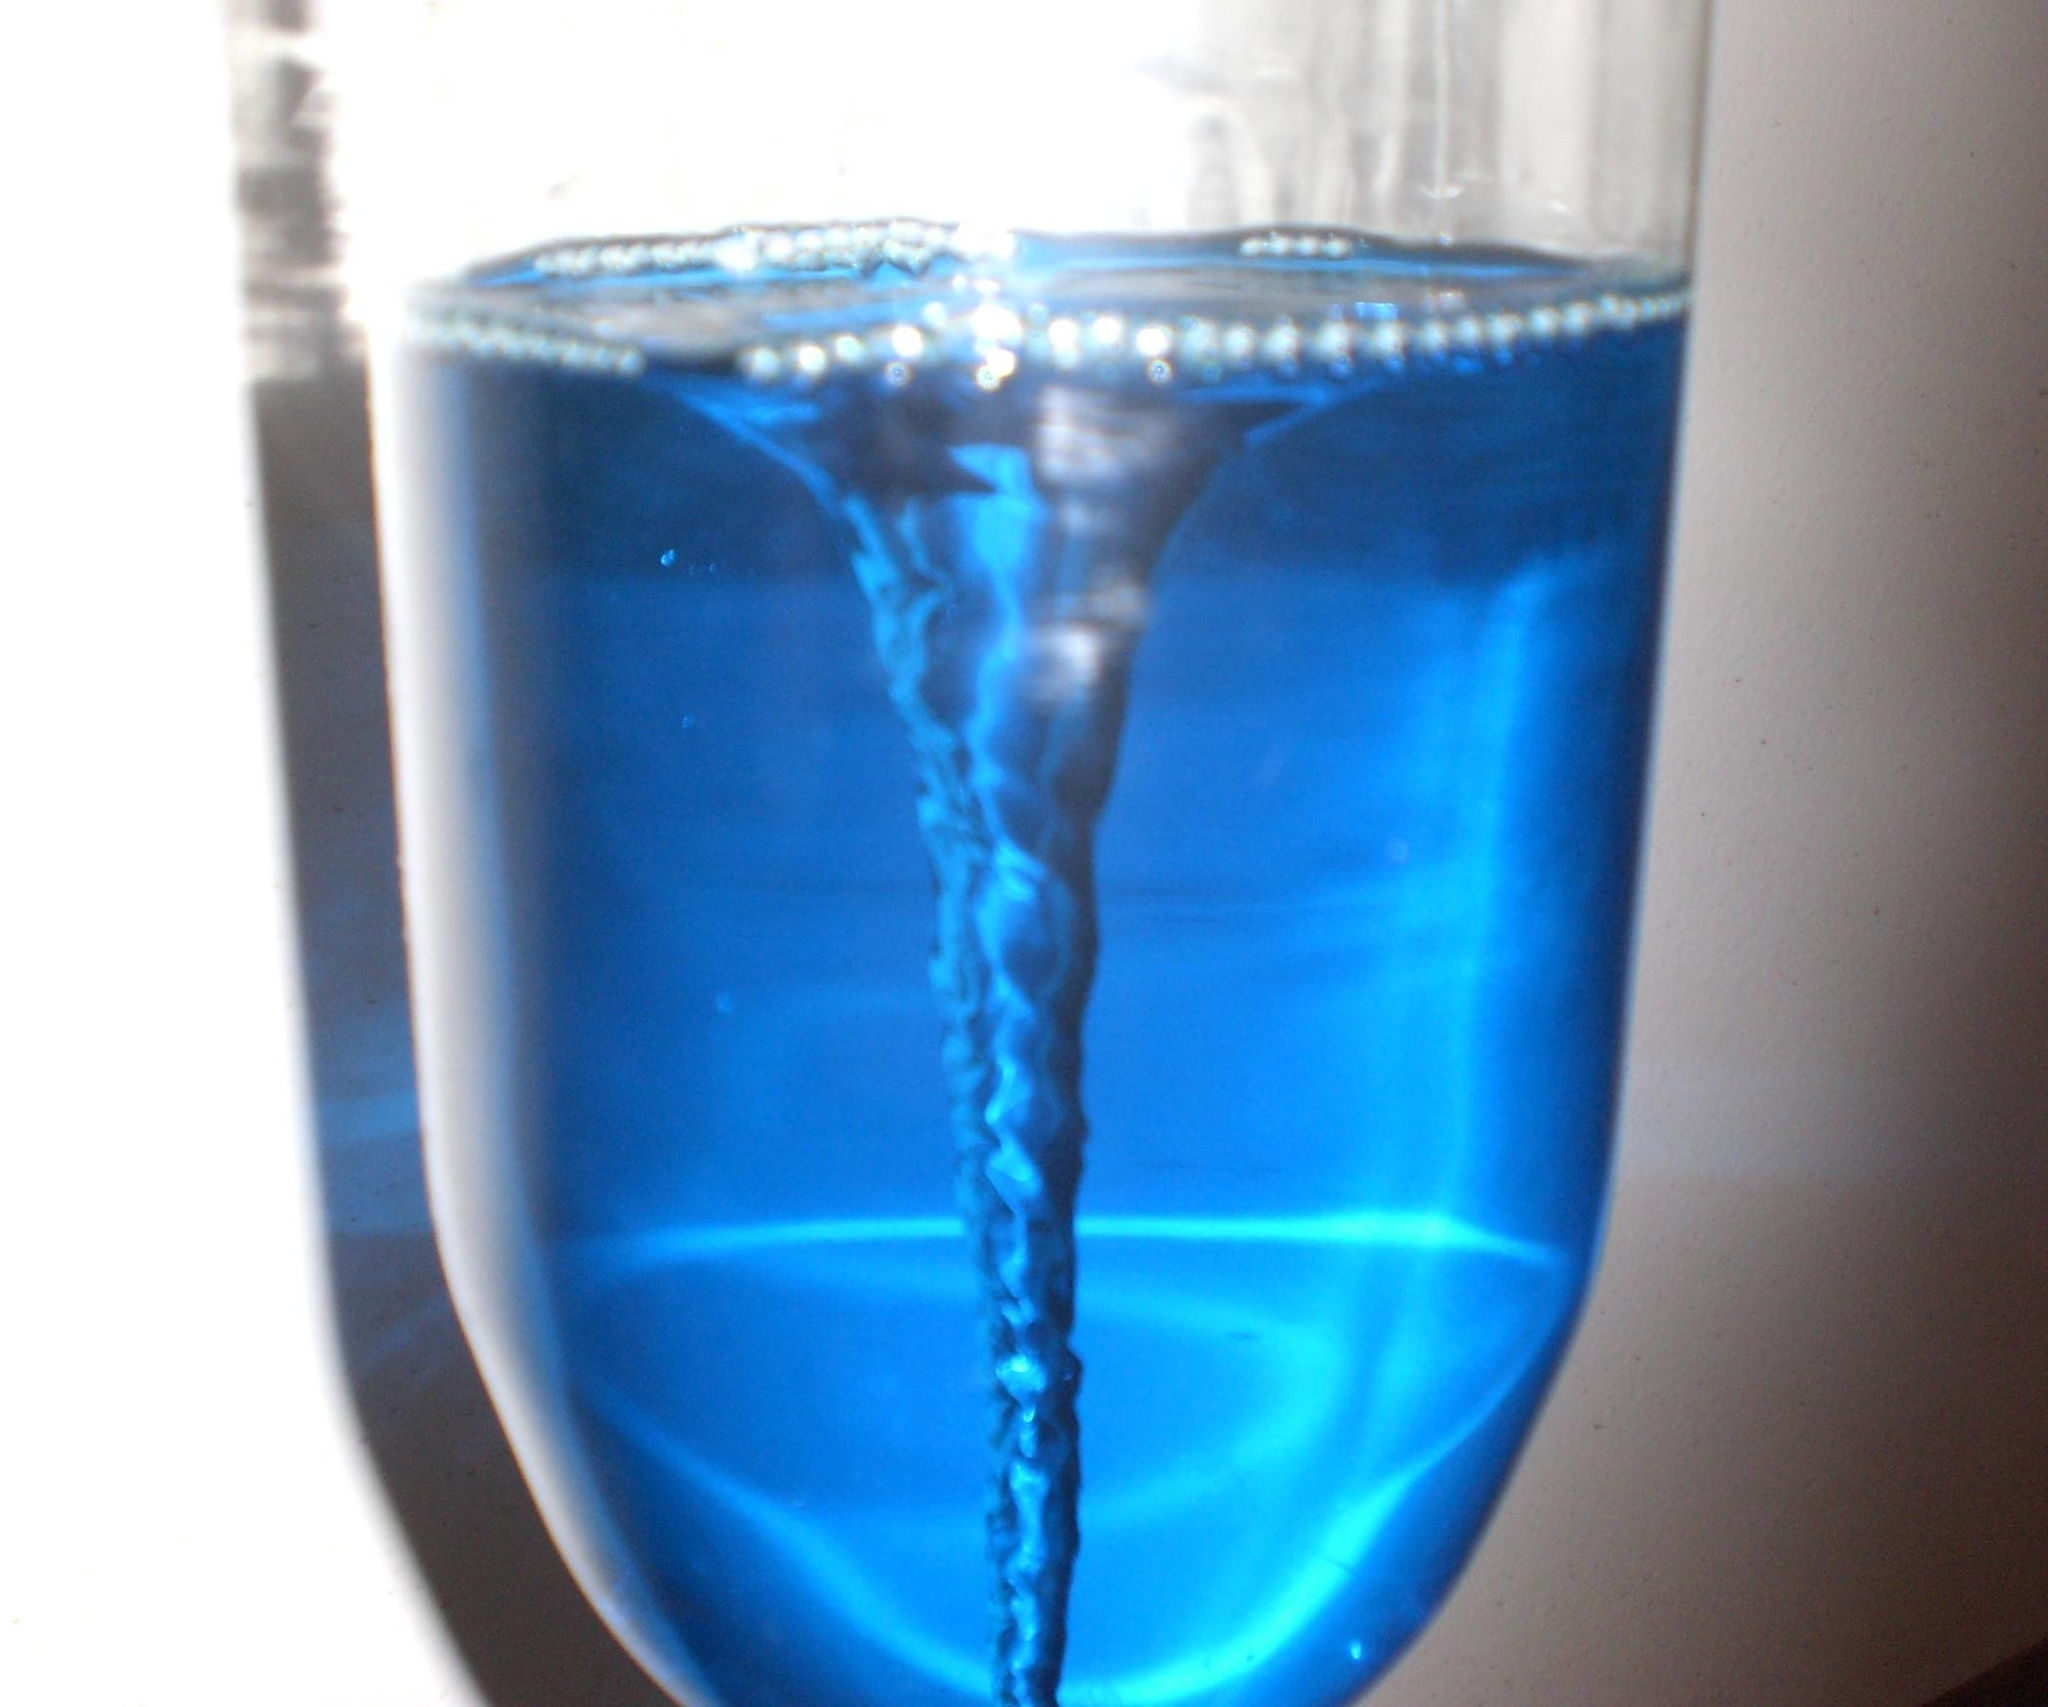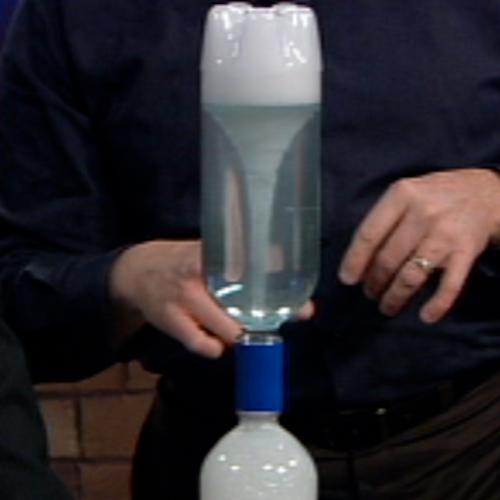The first image is the image on the left, the second image is the image on the right. Considering the images on both sides, is "One of the containers contains blue liquid." valid? Answer yes or no. Yes. The first image is the image on the left, the second image is the image on the right. Analyze the images presented: Is the assertion "In at least one image there is a make shift blue bottle funnel creating a mini tornado in blue water." valid? Answer yes or no. Yes. 